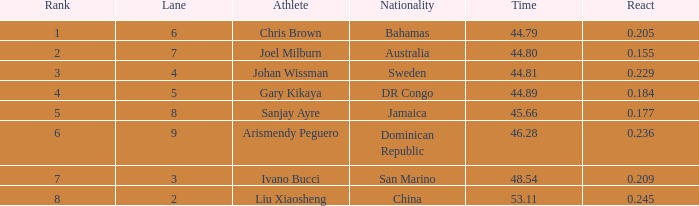What is the total average for Rank entries where the Lane listed is smaller than 4 and the Nationality listed is San Marino? 7.0. 